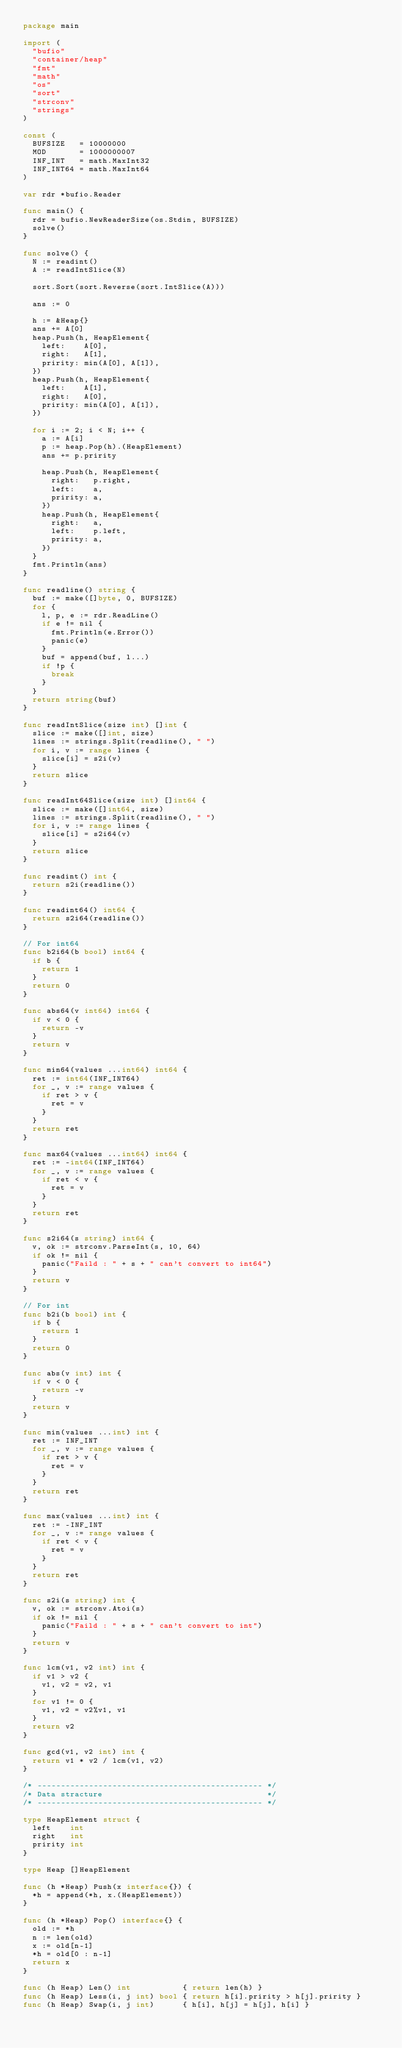Convert code to text. <code><loc_0><loc_0><loc_500><loc_500><_Go_>package main

import (
	"bufio"
	"container/heap"
	"fmt"
	"math"
	"os"
	"sort"
	"strconv"
	"strings"
)

const (
	BUFSIZE   = 10000000
	MOD       = 1000000007
	INF_INT   = math.MaxInt32
	INF_INT64 = math.MaxInt64
)

var rdr *bufio.Reader

func main() {
	rdr = bufio.NewReaderSize(os.Stdin, BUFSIZE)
	solve()
}

func solve() {
	N := readint()
	A := readIntSlice(N)

	sort.Sort(sort.Reverse(sort.IntSlice(A)))

	ans := 0

	h := &Heap{}
	ans += A[0]
	heap.Push(h, HeapElement{
		left:    A[0],
		right:   A[1],
		pririty: min(A[0], A[1]),
	})
	heap.Push(h, HeapElement{
		left:    A[1],
		right:   A[0],
		pririty: min(A[0], A[1]),
	})

	for i := 2; i < N; i++ {
		a := A[i]
		p := heap.Pop(h).(HeapElement)
		ans += p.pririty

		heap.Push(h, HeapElement{
			right:   p.right,
			left:    a,
			pririty: a,
		})
		heap.Push(h, HeapElement{
			right:   a,
			left:    p.left,
			pririty: a,
		})
	}
	fmt.Println(ans)
}

func readline() string {
	buf := make([]byte, 0, BUFSIZE)
	for {
		l, p, e := rdr.ReadLine()
		if e != nil {
			fmt.Println(e.Error())
			panic(e)
		}
		buf = append(buf, l...)
		if !p {
			break
		}
	}
	return string(buf)
}

func readIntSlice(size int) []int {
	slice := make([]int, size)
	lines := strings.Split(readline(), " ")
	for i, v := range lines {
		slice[i] = s2i(v)
	}
	return slice
}

func readInt64Slice(size int) []int64 {
	slice := make([]int64, size)
	lines := strings.Split(readline(), " ")
	for i, v := range lines {
		slice[i] = s2i64(v)
	}
	return slice
}

func readint() int {
	return s2i(readline())
}

func readint64() int64 {
	return s2i64(readline())
}

// For int64
func b2i64(b bool) int64 {
	if b {
		return 1
	}
	return 0
}

func abs64(v int64) int64 {
	if v < 0 {
		return -v
	}
	return v
}

func min64(values ...int64) int64 {
	ret := int64(INF_INT64)
	for _, v := range values {
		if ret > v {
			ret = v
		}
	}
	return ret
}

func max64(values ...int64) int64 {
	ret := -int64(INF_INT64)
	for _, v := range values {
		if ret < v {
			ret = v
		}
	}
	return ret
}

func s2i64(s string) int64 {
	v, ok := strconv.ParseInt(s, 10, 64)
	if ok != nil {
		panic("Faild : " + s + " can't convert to int64")
	}
	return v
}

// For int
func b2i(b bool) int {
	if b {
		return 1
	}
	return 0
}

func abs(v int) int {
	if v < 0 {
		return -v
	}
	return v
}

func min(values ...int) int {
	ret := INF_INT
	for _, v := range values {
		if ret > v {
			ret = v
		}
	}
	return ret
}

func max(values ...int) int {
	ret := -INF_INT
	for _, v := range values {
		if ret < v {
			ret = v
		}
	}
	return ret
}

func s2i(s string) int {
	v, ok := strconv.Atoi(s)
	if ok != nil {
		panic("Faild : " + s + " can't convert to int")
	}
	return v
}

func lcm(v1, v2 int) int {
	if v1 > v2 {
		v1, v2 = v2, v1
	}
	for v1 != 0 {
		v1, v2 = v2%v1, v1
	}
	return v2
}

func gcd(v1, v2 int) int {
	return v1 * v2 / lcm(v1, v2)
}

/* ------------------------------------------------ */
/* Data stracture                                   */
/* ------------------------------------------------ */

type HeapElement struct {
	left    int
	right   int
	pririty int
}

type Heap []HeapElement

func (h *Heap) Push(x interface{}) {
	*h = append(*h, x.(HeapElement))
}

func (h *Heap) Pop() interface{} {
	old := *h
	n := len(old)
	x := old[n-1]
	*h = old[0 : n-1]
	return x
}

func (h Heap) Len() int           { return len(h) }
func (h Heap) Less(i, j int) bool { return h[i].pririty > h[j].pririty }
func (h Heap) Swap(i, j int)      { h[i], h[j] = h[j], h[i] }
</code> 